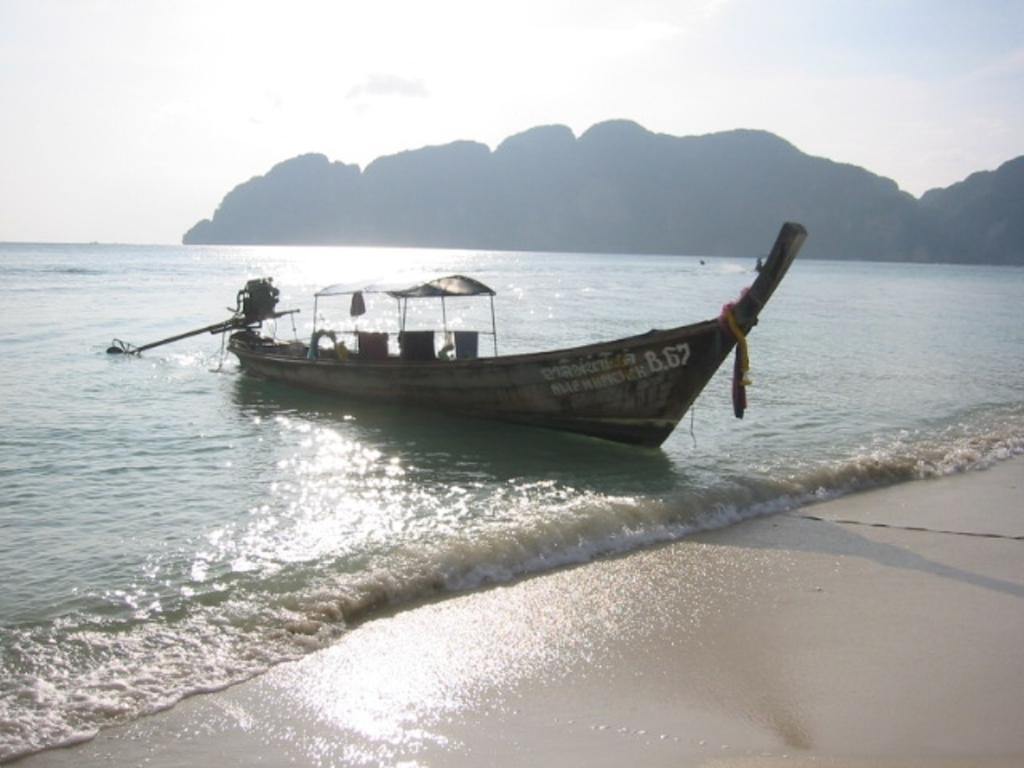What type of body of water is present in the image? There is a sea in the image. What is on the sea in the image? There is a boat on the sea. What else can be seen in the sky in the image? The sky is visible at the top of the image. What type of landform is present in the image? There is a hill in the image. Where is the sack located in the image? There is no sack present in the image. What type of wind can be seen blowing in the image? There is no wind visible in the image, and the term "zephyr" refers to a gentle breeze, which cannot be seen. 